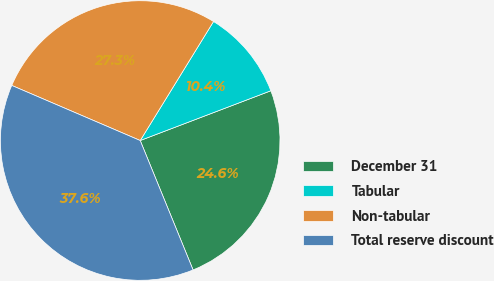Convert chart. <chart><loc_0><loc_0><loc_500><loc_500><pie_chart><fcel>December 31<fcel>Tabular<fcel>Non-tabular<fcel>Total reserve discount<nl><fcel>24.62%<fcel>10.42%<fcel>27.34%<fcel>37.62%<nl></chart> 